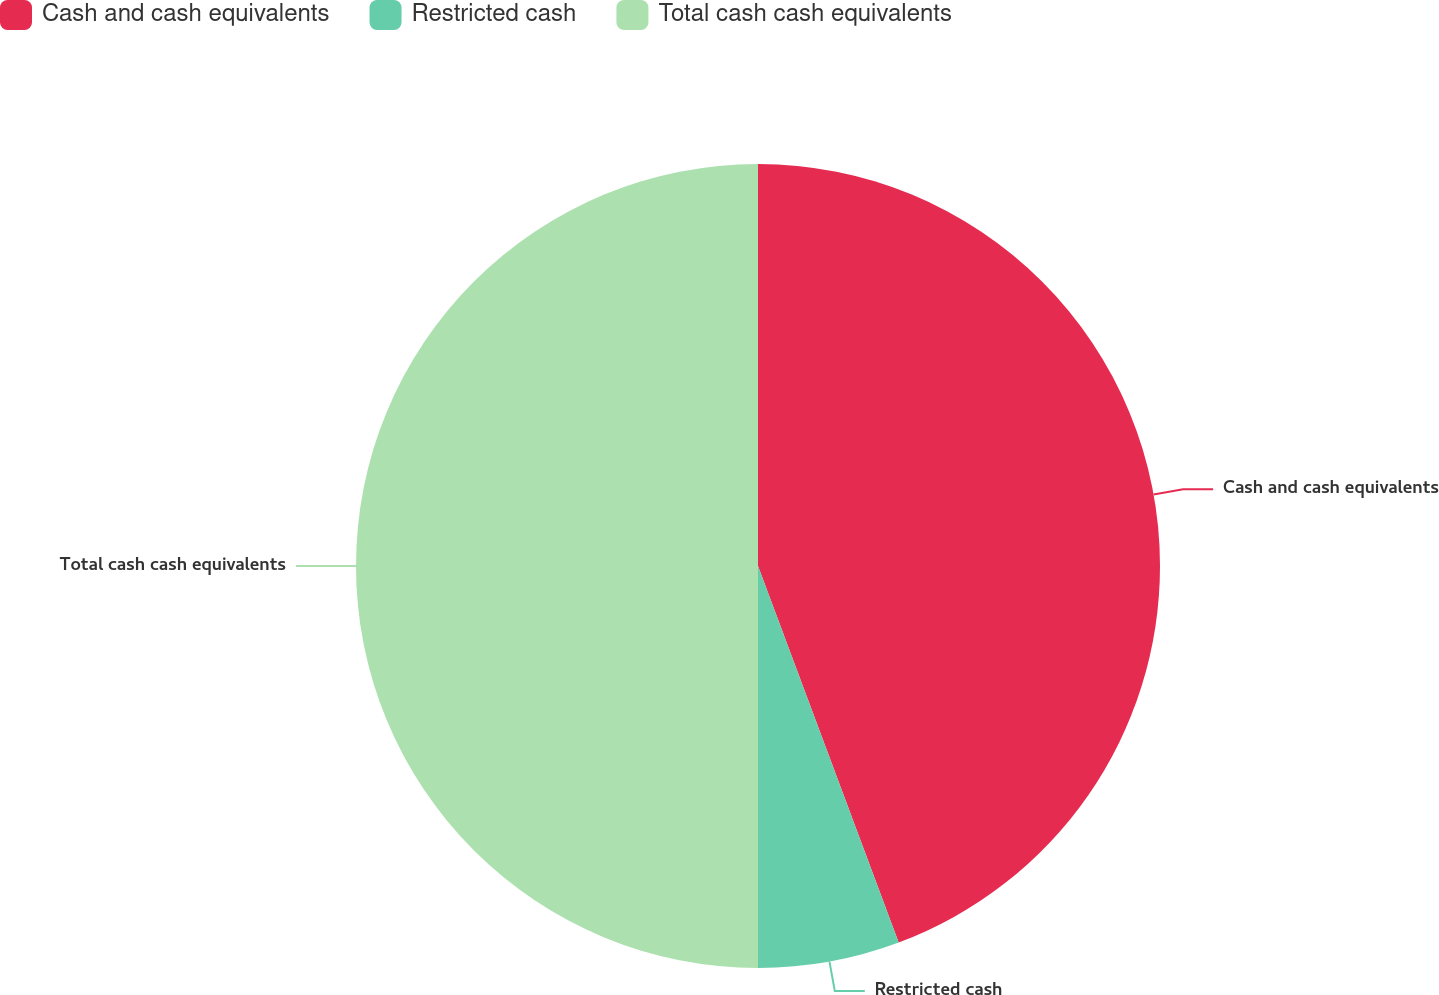Convert chart. <chart><loc_0><loc_0><loc_500><loc_500><pie_chart><fcel>Cash and cash equivalents<fcel>Restricted cash<fcel>Total cash cash equivalents<nl><fcel>44.31%<fcel>5.69%<fcel>50.0%<nl></chart> 